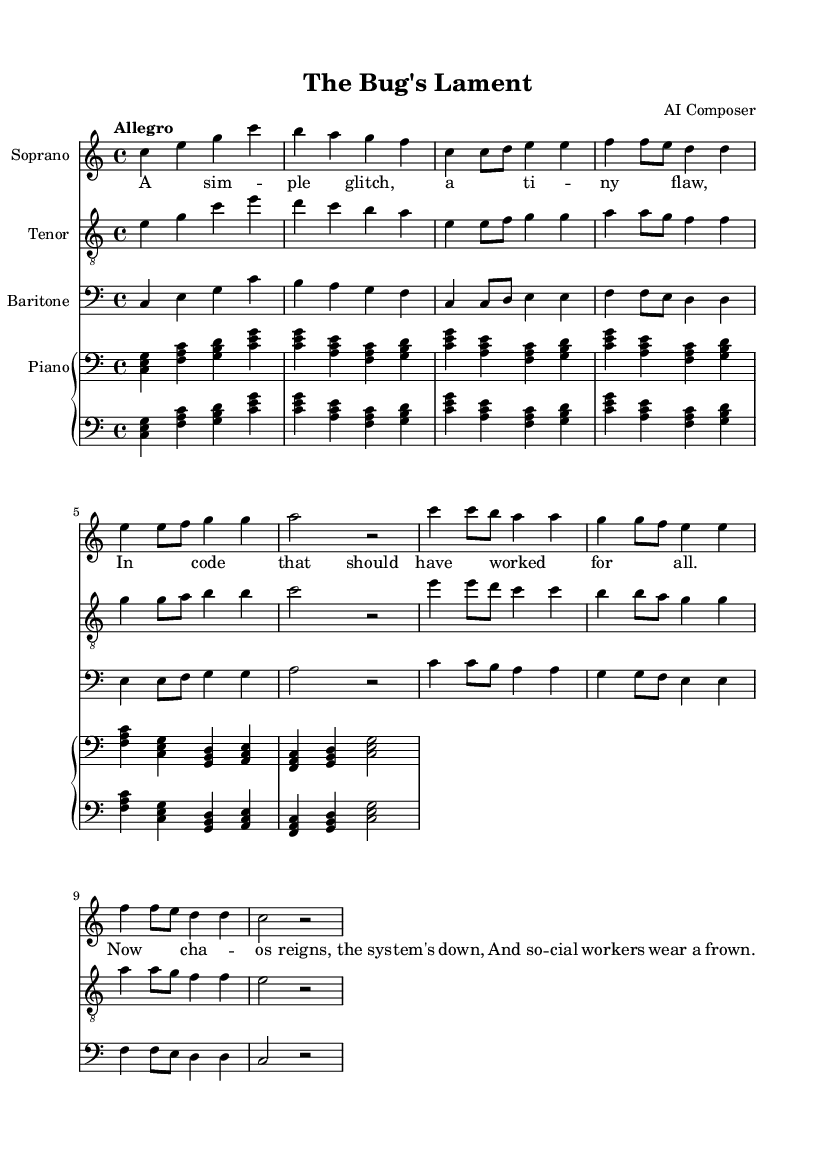What is the key signature of this music? The key signature is indicated by the absence of sharps or flats on the staff, which signifies C major.
Answer: C major What is the time signature of this music? The time signature is found at the beginning of the staff, which is written as 4/4, meaning there are four beats in a measure and the quarter note gets one beat.
Answer: 4/4 What is the tempo marking for this piece? The tempo is noted as "Allegro," which suggests a fast and lively pace.
Answer: Allegro How many measures are in the soprano part? Counting the groupings of notes, the soprano part has a total of 8 measures.
Answer: 8 What is the primary theme depicted in the lyrics? The lyrics emphasize a glitch in the software causing chaos and depict social workers in distress due to the bug.
Answer: Software glitch Which type of voice is the lowest in this piece? By examining the clef symbols and the relative pitch placement, the baritone part is the lowest since it is written in the bass clef.
Answer: Baritone How many voices are present in this opera piece? The score shows three distinct vocal parts: soprano, tenor, and baritone, indicating three voices.
Answer: Three 